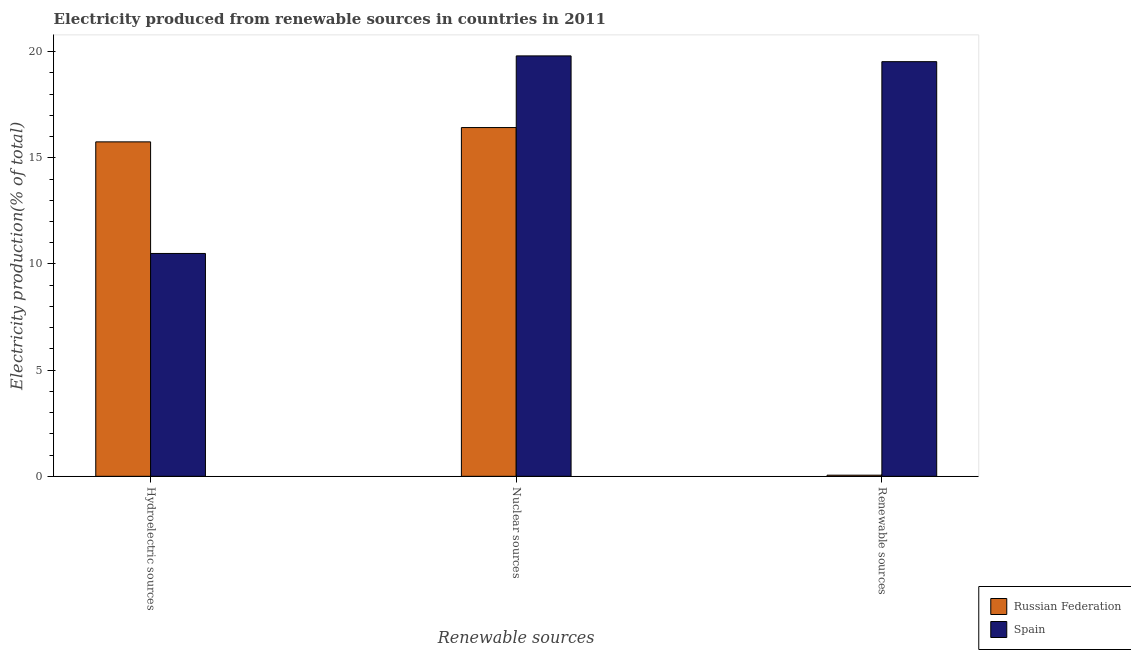How many groups of bars are there?
Make the answer very short. 3. Are the number of bars per tick equal to the number of legend labels?
Offer a very short reply. Yes. What is the label of the 2nd group of bars from the left?
Offer a very short reply. Nuclear sources. What is the percentage of electricity produced by renewable sources in Spain?
Provide a short and direct response. 19.53. Across all countries, what is the maximum percentage of electricity produced by hydroelectric sources?
Your response must be concise. 15.75. Across all countries, what is the minimum percentage of electricity produced by nuclear sources?
Ensure brevity in your answer.  16.42. In which country was the percentage of electricity produced by hydroelectric sources maximum?
Give a very brief answer. Russian Federation. In which country was the percentage of electricity produced by nuclear sources minimum?
Keep it short and to the point. Russian Federation. What is the total percentage of electricity produced by nuclear sources in the graph?
Your response must be concise. 36.22. What is the difference between the percentage of electricity produced by renewable sources in Russian Federation and that in Spain?
Give a very brief answer. -19.47. What is the difference between the percentage of electricity produced by nuclear sources in Russian Federation and the percentage of electricity produced by renewable sources in Spain?
Provide a short and direct response. -3.1. What is the average percentage of electricity produced by nuclear sources per country?
Offer a terse response. 18.11. What is the difference between the percentage of electricity produced by hydroelectric sources and percentage of electricity produced by nuclear sources in Spain?
Keep it short and to the point. -9.3. In how many countries, is the percentage of electricity produced by nuclear sources greater than 19 %?
Provide a short and direct response. 1. What is the ratio of the percentage of electricity produced by renewable sources in Russian Federation to that in Spain?
Offer a very short reply. 0. Is the difference between the percentage of electricity produced by hydroelectric sources in Spain and Russian Federation greater than the difference between the percentage of electricity produced by nuclear sources in Spain and Russian Federation?
Offer a very short reply. No. What is the difference between the highest and the second highest percentage of electricity produced by nuclear sources?
Offer a terse response. 3.37. What is the difference between the highest and the lowest percentage of electricity produced by nuclear sources?
Provide a succinct answer. 3.37. In how many countries, is the percentage of electricity produced by nuclear sources greater than the average percentage of electricity produced by nuclear sources taken over all countries?
Offer a very short reply. 1. Is the sum of the percentage of electricity produced by renewable sources in Russian Federation and Spain greater than the maximum percentage of electricity produced by hydroelectric sources across all countries?
Ensure brevity in your answer.  Yes. What does the 2nd bar from the left in Nuclear sources represents?
Your response must be concise. Spain. Is it the case that in every country, the sum of the percentage of electricity produced by hydroelectric sources and percentage of electricity produced by nuclear sources is greater than the percentage of electricity produced by renewable sources?
Offer a very short reply. Yes. How many bars are there?
Keep it short and to the point. 6. Are all the bars in the graph horizontal?
Keep it short and to the point. No. Does the graph contain grids?
Make the answer very short. No. How are the legend labels stacked?
Your answer should be very brief. Vertical. What is the title of the graph?
Provide a short and direct response. Electricity produced from renewable sources in countries in 2011. What is the label or title of the X-axis?
Provide a succinct answer. Renewable sources. What is the label or title of the Y-axis?
Provide a succinct answer. Electricity production(% of total). What is the Electricity production(% of total) of Russian Federation in Hydroelectric sources?
Provide a short and direct response. 15.75. What is the Electricity production(% of total) of Spain in Hydroelectric sources?
Give a very brief answer. 10.49. What is the Electricity production(% of total) in Russian Federation in Nuclear sources?
Provide a short and direct response. 16.42. What is the Electricity production(% of total) of Spain in Nuclear sources?
Ensure brevity in your answer.  19.8. What is the Electricity production(% of total) of Russian Federation in Renewable sources?
Offer a terse response. 0.05. What is the Electricity production(% of total) in Spain in Renewable sources?
Ensure brevity in your answer.  19.53. Across all Renewable sources, what is the maximum Electricity production(% of total) of Russian Federation?
Offer a very short reply. 16.42. Across all Renewable sources, what is the maximum Electricity production(% of total) of Spain?
Your answer should be very brief. 19.8. Across all Renewable sources, what is the minimum Electricity production(% of total) of Russian Federation?
Provide a succinct answer. 0.05. Across all Renewable sources, what is the minimum Electricity production(% of total) in Spain?
Offer a very short reply. 10.49. What is the total Electricity production(% of total) of Russian Federation in the graph?
Make the answer very short. 32.23. What is the total Electricity production(% of total) of Spain in the graph?
Your answer should be very brief. 49.82. What is the difference between the Electricity production(% of total) of Russian Federation in Hydroelectric sources and that in Nuclear sources?
Your answer should be compact. -0.67. What is the difference between the Electricity production(% of total) in Spain in Hydroelectric sources and that in Nuclear sources?
Your answer should be compact. -9.3. What is the difference between the Electricity production(% of total) of Russian Federation in Hydroelectric sources and that in Renewable sources?
Ensure brevity in your answer.  15.7. What is the difference between the Electricity production(% of total) in Spain in Hydroelectric sources and that in Renewable sources?
Give a very brief answer. -9.03. What is the difference between the Electricity production(% of total) of Russian Federation in Nuclear sources and that in Renewable sources?
Provide a succinct answer. 16.37. What is the difference between the Electricity production(% of total) of Spain in Nuclear sources and that in Renewable sources?
Your answer should be very brief. 0.27. What is the difference between the Electricity production(% of total) of Russian Federation in Hydroelectric sources and the Electricity production(% of total) of Spain in Nuclear sources?
Offer a very short reply. -4.05. What is the difference between the Electricity production(% of total) of Russian Federation in Hydroelectric sources and the Electricity production(% of total) of Spain in Renewable sources?
Make the answer very short. -3.78. What is the difference between the Electricity production(% of total) in Russian Federation in Nuclear sources and the Electricity production(% of total) in Spain in Renewable sources?
Keep it short and to the point. -3.1. What is the average Electricity production(% of total) of Russian Federation per Renewable sources?
Provide a short and direct response. 10.74. What is the average Electricity production(% of total) of Spain per Renewable sources?
Provide a succinct answer. 16.61. What is the difference between the Electricity production(% of total) of Russian Federation and Electricity production(% of total) of Spain in Hydroelectric sources?
Offer a very short reply. 5.25. What is the difference between the Electricity production(% of total) in Russian Federation and Electricity production(% of total) in Spain in Nuclear sources?
Offer a terse response. -3.37. What is the difference between the Electricity production(% of total) in Russian Federation and Electricity production(% of total) in Spain in Renewable sources?
Your answer should be very brief. -19.47. What is the ratio of the Electricity production(% of total) of Spain in Hydroelectric sources to that in Nuclear sources?
Ensure brevity in your answer.  0.53. What is the ratio of the Electricity production(% of total) in Russian Federation in Hydroelectric sources to that in Renewable sources?
Give a very brief answer. 295.1. What is the ratio of the Electricity production(% of total) of Spain in Hydroelectric sources to that in Renewable sources?
Provide a succinct answer. 0.54. What is the ratio of the Electricity production(% of total) in Russian Federation in Nuclear sources to that in Renewable sources?
Your response must be concise. 307.72. What is the ratio of the Electricity production(% of total) of Spain in Nuclear sources to that in Renewable sources?
Offer a terse response. 1.01. What is the difference between the highest and the second highest Electricity production(% of total) in Russian Federation?
Offer a very short reply. 0.67. What is the difference between the highest and the second highest Electricity production(% of total) in Spain?
Keep it short and to the point. 0.27. What is the difference between the highest and the lowest Electricity production(% of total) in Russian Federation?
Your answer should be compact. 16.37. What is the difference between the highest and the lowest Electricity production(% of total) of Spain?
Provide a short and direct response. 9.3. 